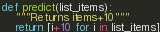Convert code to text. <code><loc_0><loc_0><loc_500><loc_500><_Python_>
def predict(list_items):
    """Returns items+10"""
    return [i+10 for i in list_items]
</code> 